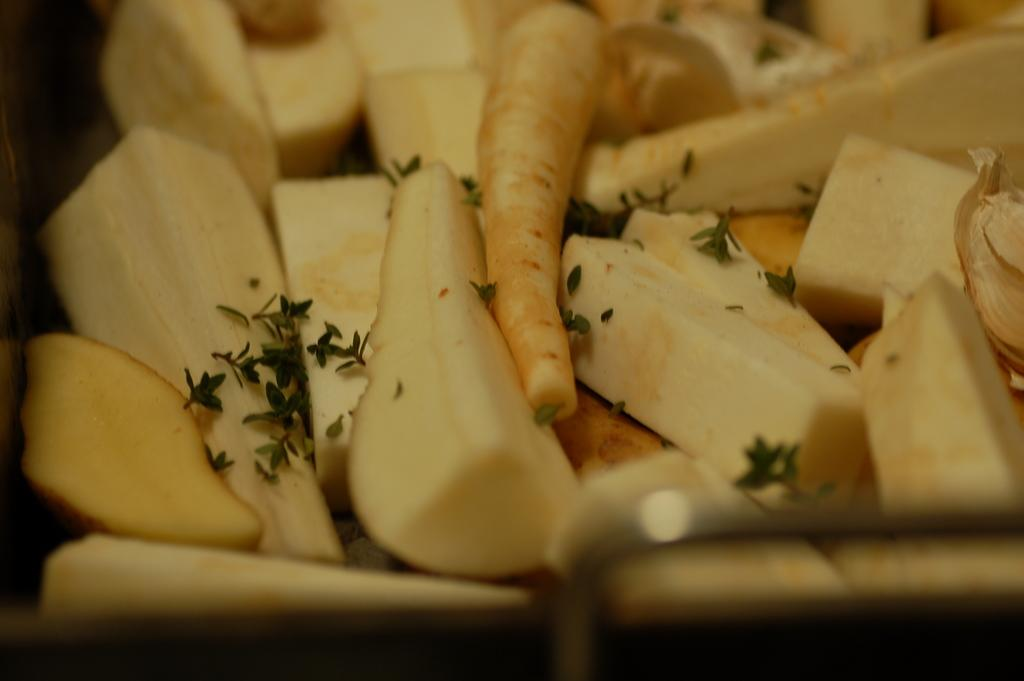What is the main subject of the image? The main subject of the image is food items. Is there a squirrel using a hook to spark a fire in the image? No, there is no squirrel or hook present in the image, and no fire is depicted either. 